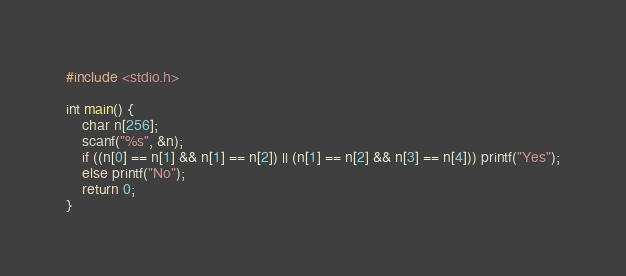<code> <loc_0><loc_0><loc_500><loc_500><_C_>#include <stdio.h>

int main() {
	char n[256];
	scanf("%s", &n);
	if ((n[0] == n[1] && n[1] == n[2]) || (n[1] == n[2] && n[3] == n[4])) printf("Yes");
	else printf("No");
	return 0;
}</code> 